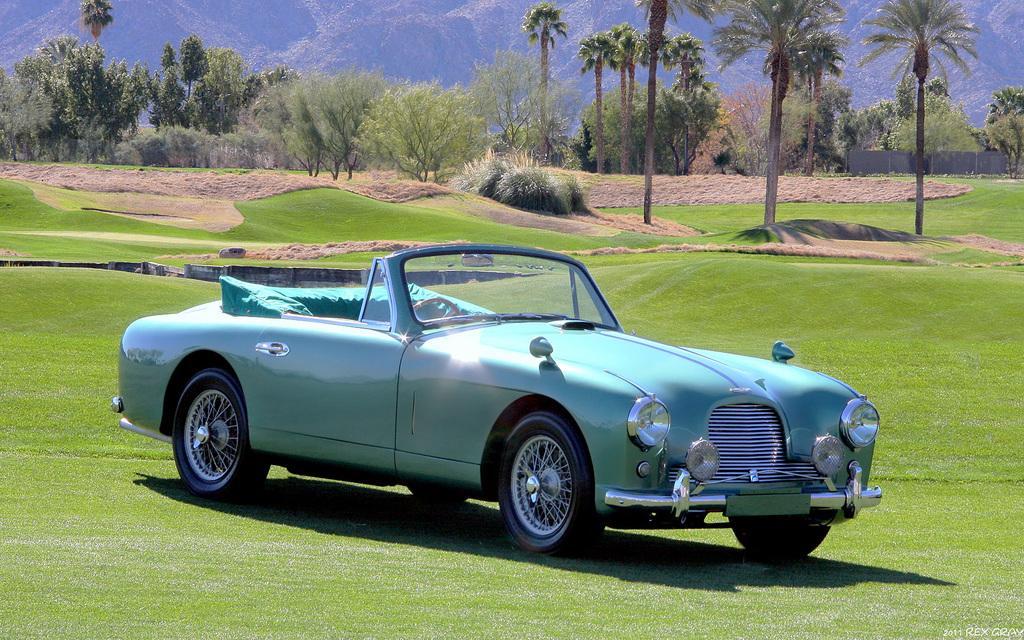Could you give a brief overview of what you see in this image? As we can see in the image there is a car, grass, plants, trees and hills. 